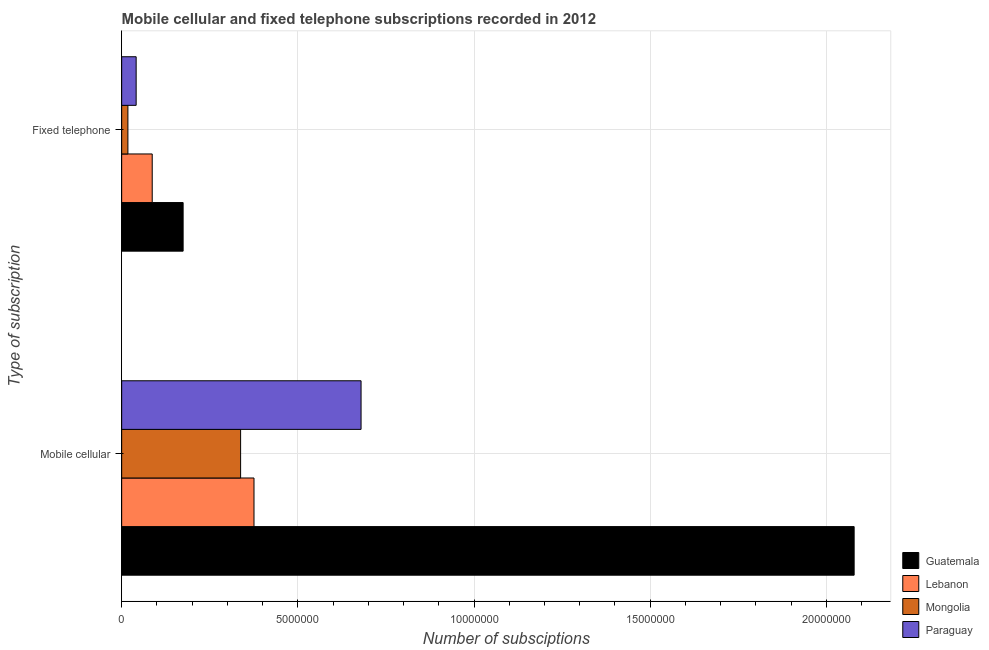How many different coloured bars are there?
Make the answer very short. 4. Are the number of bars per tick equal to the number of legend labels?
Keep it short and to the point. Yes. What is the label of the 1st group of bars from the top?
Ensure brevity in your answer.  Fixed telephone. What is the number of mobile cellular subscriptions in Guatemala?
Keep it short and to the point. 2.08e+07. Across all countries, what is the maximum number of fixed telephone subscriptions?
Offer a terse response. 1.74e+06. Across all countries, what is the minimum number of fixed telephone subscriptions?
Give a very brief answer. 1.77e+05. In which country was the number of mobile cellular subscriptions maximum?
Make the answer very short. Guatemala. In which country was the number of mobile cellular subscriptions minimum?
Provide a succinct answer. Mongolia. What is the total number of mobile cellular subscriptions in the graph?
Provide a short and direct response. 3.47e+07. What is the difference between the number of fixed telephone subscriptions in Mongolia and that in Guatemala?
Your answer should be compact. -1.57e+06. What is the difference between the number of mobile cellular subscriptions in Mongolia and the number of fixed telephone subscriptions in Lebanon?
Offer a very short reply. 2.51e+06. What is the average number of mobile cellular subscriptions per country?
Your answer should be very brief. 8.68e+06. What is the difference between the number of mobile cellular subscriptions and number of fixed telephone subscriptions in Guatemala?
Make the answer very short. 1.90e+07. What is the ratio of the number of mobile cellular subscriptions in Paraguay to that in Guatemala?
Keep it short and to the point. 0.33. What does the 1st bar from the top in Mobile cellular represents?
Ensure brevity in your answer.  Paraguay. What does the 3rd bar from the bottom in Mobile cellular represents?
Ensure brevity in your answer.  Mongolia. Where does the legend appear in the graph?
Offer a terse response. Bottom right. How are the legend labels stacked?
Keep it short and to the point. Vertical. What is the title of the graph?
Your response must be concise. Mobile cellular and fixed telephone subscriptions recorded in 2012. Does "Bermuda" appear as one of the legend labels in the graph?
Keep it short and to the point. No. What is the label or title of the X-axis?
Give a very brief answer. Number of subsciptions. What is the label or title of the Y-axis?
Offer a terse response. Type of subscription. What is the Number of subsciptions in Guatemala in Mobile cellular?
Offer a terse response. 2.08e+07. What is the Number of subsciptions in Lebanon in Mobile cellular?
Provide a short and direct response. 3.76e+06. What is the Number of subsciptions in Mongolia in Mobile cellular?
Keep it short and to the point. 3.38e+06. What is the Number of subsciptions in Paraguay in Mobile cellular?
Make the answer very short. 6.79e+06. What is the Number of subsciptions in Guatemala in Fixed telephone?
Keep it short and to the point. 1.74e+06. What is the Number of subsciptions in Lebanon in Fixed telephone?
Make the answer very short. 8.67e+05. What is the Number of subsciptions in Mongolia in Fixed telephone?
Your answer should be compact. 1.77e+05. What is the Number of subsciptions in Paraguay in Fixed telephone?
Offer a very short reply. 4.11e+05. Across all Type of subscription, what is the maximum Number of subsciptions of Guatemala?
Your answer should be compact. 2.08e+07. Across all Type of subscription, what is the maximum Number of subsciptions in Lebanon?
Offer a terse response. 3.76e+06. Across all Type of subscription, what is the maximum Number of subsciptions of Mongolia?
Your response must be concise. 3.38e+06. Across all Type of subscription, what is the maximum Number of subsciptions in Paraguay?
Provide a short and direct response. 6.79e+06. Across all Type of subscription, what is the minimum Number of subsciptions of Guatemala?
Offer a terse response. 1.74e+06. Across all Type of subscription, what is the minimum Number of subsciptions in Lebanon?
Your answer should be compact. 8.67e+05. Across all Type of subscription, what is the minimum Number of subsciptions of Mongolia?
Your answer should be very brief. 1.77e+05. Across all Type of subscription, what is the minimum Number of subsciptions in Paraguay?
Offer a terse response. 4.11e+05. What is the total Number of subsciptions in Guatemala in the graph?
Offer a very short reply. 2.25e+07. What is the total Number of subsciptions in Lebanon in the graph?
Provide a succinct answer. 4.62e+06. What is the total Number of subsciptions of Mongolia in the graph?
Offer a very short reply. 3.55e+06. What is the total Number of subsciptions of Paraguay in the graph?
Offer a very short reply. 7.20e+06. What is the difference between the Number of subsciptions of Guatemala in Mobile cellular and that in Fixed telephone?
Keep it short and to the point. 1.90e+07. What is the difference between the Number of subsciptions of Lebanon in Mobile cellular and that in Fixed telephone?
Your response must be concise. 2.89e+06. What is the difference between the Number of subsciptions of Mongolia in Mobile cellular and that in Fixed telephone?
Ensure brevity in your answer.  3.20e+06. What is the difference between the Number of subsciptions in Paraguay in Mobile cellular and that in Fixed telephone?
Offer a very short reply. 6.38e+06. What is the difference between the Number of subsciptions in Guatemala in Mobile cellular and the Number of subsciptions in Lebanon in Fixed telephone?
Your response must be concise. 1.99e+07. What is the difference between the Number of subsciptions of Guatemala in Mobile cellular and the Number of subsciptions of Mongolia in Fixed telephone?
Provide a short and direct response. 2.06e+07. What is the difference between the Number of subsciptions in Guatemala in Mobile cellular and the Number of subsciptions in Paraguay in Fixed telephone?
Your answer should be very brief. 2.04e+07. What is the difference between the Number of subsciptions in Lebanon in Mobile cellular and the Number of subsciptions in Mongolia in Fixed telephone?
Provide a succinct answer. 3.58e+06. What is the difference between the Number of subsciptions in Lebanon in Mobile cellular and the Number of subsciptions in Paraguay in Fixed telephone?
Your answer should be compact. 3.34e+06. What is the difference between the Number of subsciptions in Mongolia in Mobile cellular and the Number of subsciptions in Paraguay in Fixed telephone?
Give a very brief answer. 2.96e+06. What is the average Number of subsciptions in Guatemala per Type of subscription?
Provide a succinct answer. 1.13e+07. What is the average Number of subsciptions in Lebanon per Type of subscription?
Your response must be concise. 2.31e+06. What is the average Number of subsciptions of Mongolia per Type of subscription?
Keep it short and to the point. 1.78e+06. What is the average Number of subsciptions in Paraguay per Type of subscription?
Your answer should be compact. 3.60e+06. What is the difference between the Number of subsciptions of Guatemala and Number of subsciptions of Lebanon in Mobile cellular?
Your response must be concise. 1.70e+07. What is the difference between the Number of subsciptions in Guatemala and Number of subsciptions in Mongolia in Mobile cellular?
Offer a very short reply. 1.74e+07. What is the difference between the Number of subsciptions in Guatemala and Number of subsciptions in Paraguay in Mobile cellular?
Your answer should be very brief. 1.40e+07. What is the difference between the Number of subsciptions of Lebanon and Number of subsciptions of Mongolia in Mobile cellular?
Make the answer very short. 3.80e+05. What is the difference between the Number of subsciptions of Lebanon and Number of subsciptions of Paraguay in Mobile cellular?
Ensure brevity in your answer.  -3.04e+06. What is the difference between the Number of subsciptions in Mongolia and Number of subsciptions in Paraguay in Mobile cellular?
Provide a succinct answer. -3.42e+06. What is the difference between the Number of subsciptions of Guatemala and Number of subsciptions of Lebanon in Fixed telephone?
Ensure brevity in your answer.  8.77e+05. What is the difference between the Number of subsciptions in Guatemala and Number of subsciptions in Mongolia in Fixed telephone?
Your answer should be very brief. 1.57e+06. What is the difference between the Number of subsciptions in Guatemala and Number of subsciptions in Paraguay in Fixed telephone?
Make the answer very short. 1.33e+06. What is the difference between the Number of subsciptions in Lebanon and Number of subsciptions in Mongolia in Fixed telephone?
Make the answer very short. 6.90e+05. What is the difference between the Number of subsciptions of Lebanon and Number of subsciptions of Paraguay in Fixed telephone?
Offer a very short reply. 4.56e+05. What is the difference between the Number of subsciptions in Mongolia and Number of subsciptions in Paraguay in Fixed telephone?
Your answer should be compact. -2.34e+05. What is the ratio of the Number of subsciptions in Guatemala in Mobile cellular to that in Fixed telephone?
Make the answer very short. 11.92. What is the ratio of the Number of subsciptions in Lebanon in Mobile cellular to that in Fixed telephone?
Give a very brief answer. 4.33. What is the ratio of the Number of subsciptions of Mongolia in Mobile cellular to that in Fixed telephone?
Provide a succinct answer. 19.1. What is the ratio of the Number of subsciptions in Paraguay in Mobile cellular to that in Fixed telephone?
Make the answer very short. 16.53. What is the difference between the highest and the second highest Number of subsciptions in Guatemala?
Ensure brevity in your answer.  1.90e+07. What is the difference between the highest and the second highest Number of subsciptions in Lebanon?
Your answer should be compact. 2.89e+06. What is the difference between the highest and the second highest Number of subsciptions of Mongolia?
Your answer should be very brief. 3.20e+06. What is the difference between the highest and the second highest Number of subsciptions in Paraguay?
Your answer should be compact. 6.38e+06. What is the difference between the highest and the lowest Number of subsciptions in Guatemala?
Your response must be concise. 1.90e+07. What is the difference between the highest and the lowest Number of subsciptions in Lebanon?
Offer a terse response. 2.89e+06. What is the difference between the highest and the lowest Number of subsciptions in Mongolia?
Your answer should be compact. 3.20e+06. What is the difference between the highest and the lowest Number of subsciptions of Paraguay?
Your response must be concise. 6.38e+06. 